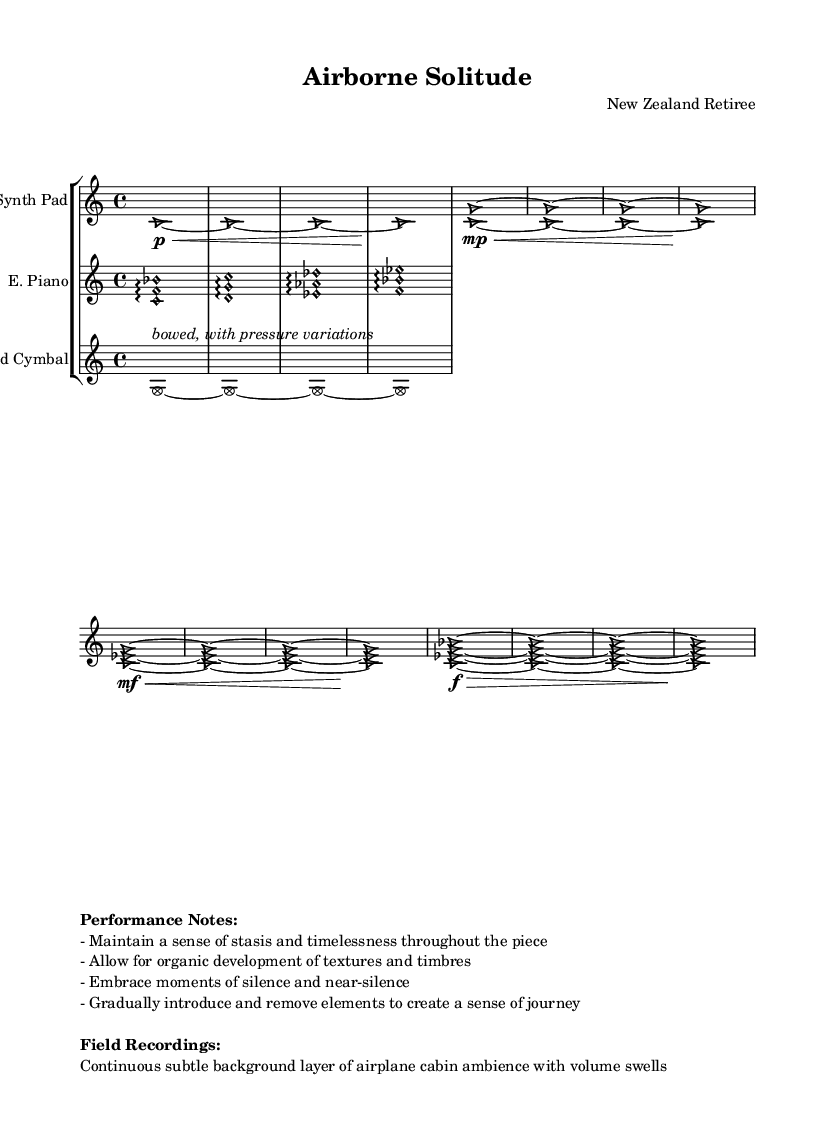What is the title of this piece? The title is displayed in the header section of the sheet music. It reads "Airborne Solitude".
Answer: Airborne Solitude What is the time signature? The time signature is indicated at the beginning of the staff. It is written as 4/4, meaning there are four beats per measure.
Answer: 4/4 How many instruments are present in the score? The score includes three staves, each representing a different instrument, as indicated in the StaffGroup section.
Answer: Three What dynamics are used in the synth pad section? The dynamics are indicated with symbols next to the notes in the synth pad part. It shows piano, mezzo-piano, mezzo-forte, and forte, specifying varying levels of loudness.
Answer: piano, mezzo-piano, mezzo-forte, forte Which instrument has arpeggiated passages? The electric piano section has notes marked with the arpeggio symbol, indicating that the notes should be played in an arpeggiated manner.
Answer: Electric Piano What performance note suggests the use of silence? One of the performance notes specifically mentions embracing moments of silence and near-silence, which is crucial in creating tension and space in ambient music.
Answer: Embrace moments of silence Which instrument uses the technique of bowing? The bowed cymbal part explicitly includes a markup note indicating that it should be bowed, highlighting a unique playing technique associated with that instrument.
Answer: Bowed Cymbal 